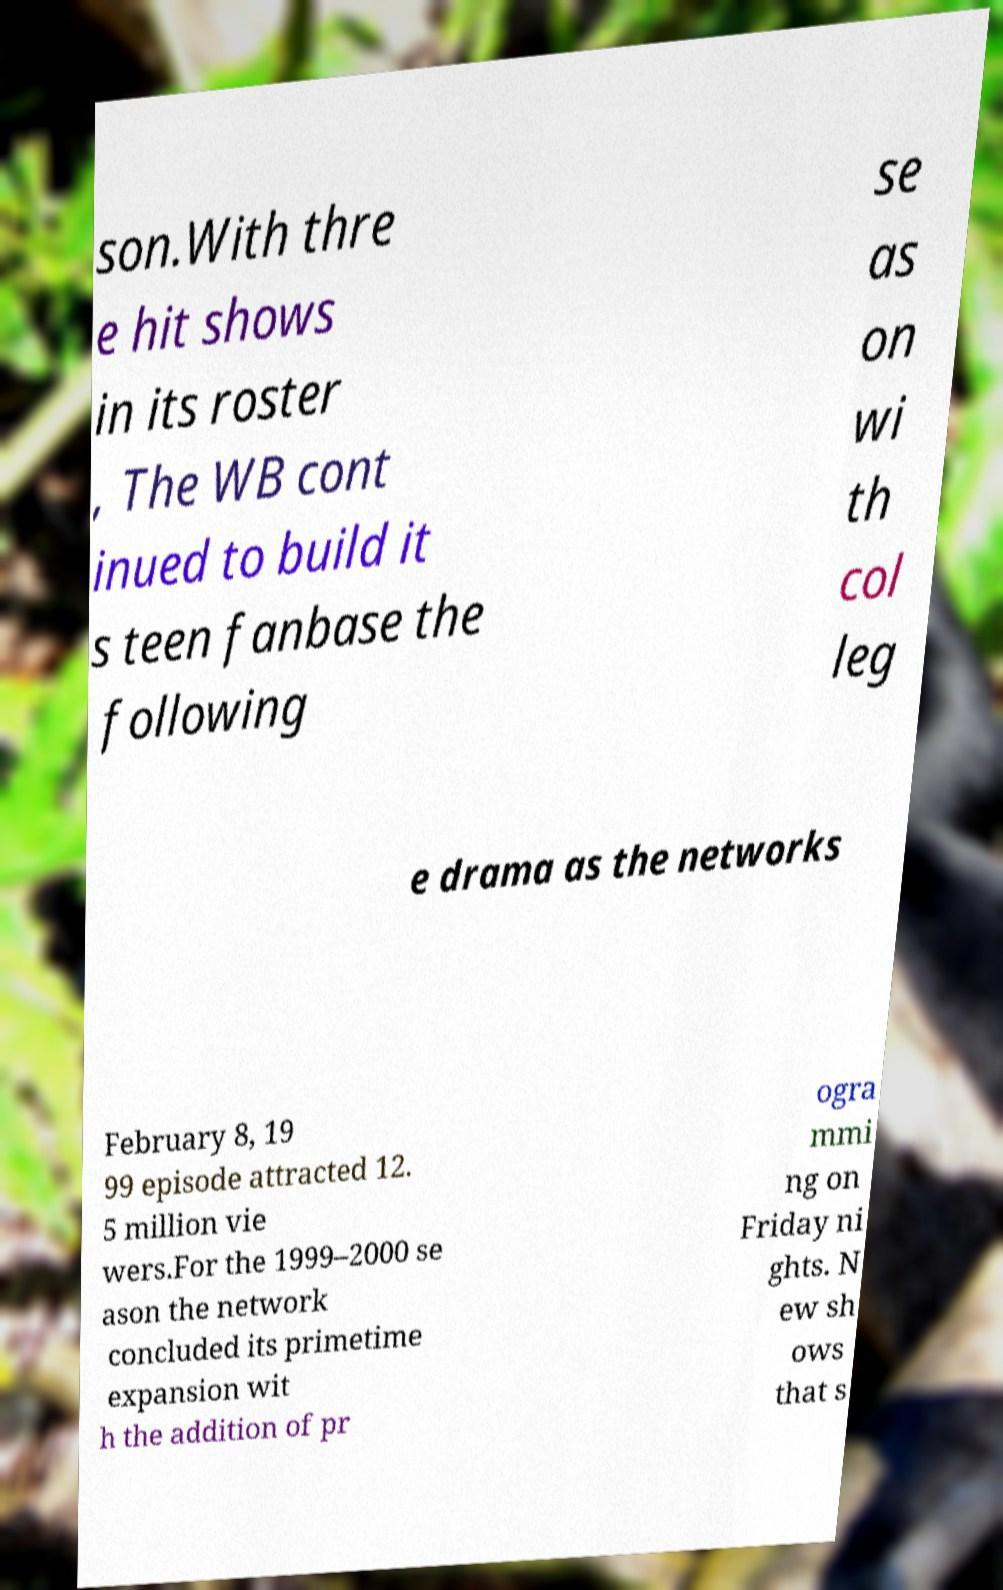Can you accurately transcribe the text from the provided image for me? son.With thre e hit shows in its roster , The WB cont inued to build it s teen fanbase the following se as on wi th col leg e drama as the networks February 8, 19 99 episode attracted 12. 5 million vie wers.For the 1999–2000 se ason the network concluded its primetime expansion wit h the addition of pr ogra mmi ng on Friday ni ghts. N ew sh ows that s 